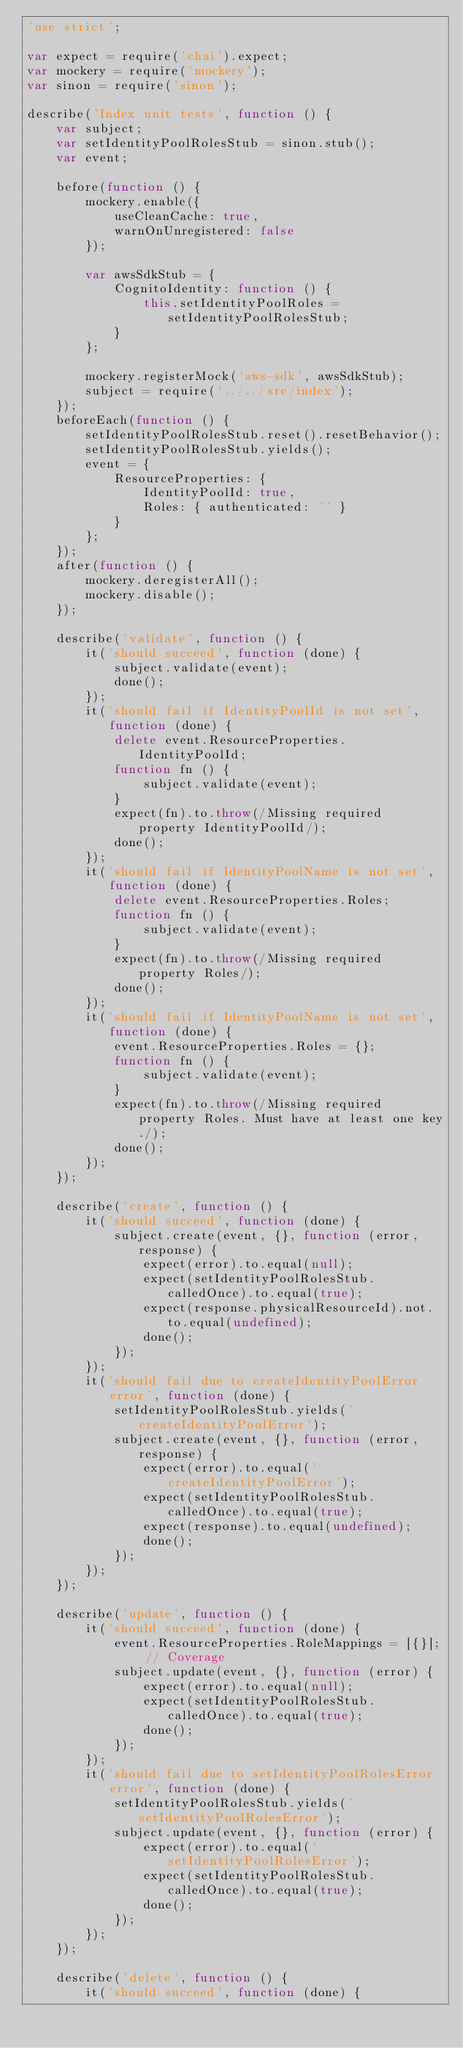<code> <loc_0><loc_0><loc_500><loc_500><_JavaScript_>'use strict';

var expect = require('chai').expect;
var mockery = require('mockery');
var sinon = require('sinon');

describe('Index unit tests', function () {
    var subject;
    var setIdentityPoolRolesStub = sinon.stub();
    var event;

    before(function () {
        mockery.enable({
            useCleanCache: true,
            warnOnUnregistered: false
        });

        var awsSdkStub = {
            CognitoIdentity: function () {
                this.setIdentityPoolRoles = setIdentityPoolRolesStub;
            }
        };

        mockery.registerMock('aws-sdk', awsSdkStub);
        subject = require('../../src/index');
    });
    beforeEach(function () {
        setIdentityPoolRolesStub.reset().resetBehavior();
        setIdentityPoolRolesStub.yields();
        event = {
            ResourceProperties: {
                IdentityPoolId: true,
                Roles: { authenticated: '' }
            }
        };
    });
    after(function () {
        mockery.deregisterAll();
        mockery.disable();
    });

    describe('validate', function () {
        it('should succeed', function (done) {
            subject.validate(event);
            done();
        });
        it('should fail if IdentityPoolId is not set', function (done) {
            delete event.ResourceProperties.IdentityPoolId;
            function fn () {
                subject.validate(event);
            }
            expect(fn).to.throw(/Missing required property IdentityPoolId/);
            done();
        });
        it('should fail if IdentityPoolName is not set', function (done) {
            delete event.ResourceProperties.Roles;
            function fn () {
                subject.validate(event);
            }
            expect(fn).to.throw(/Missing required property Roles/);
            done();
        });
        it('should fail if IdentityPoolName is not set', function (done) {
            event.ResourceProperties.Roles = {};
            function fn () {
                subject.validate(event);
            }
            expect(fn).to.throw(/Missing required property Roles. Must have at least one key./);
            done();
        });
    });

    describe('create', function () {
        it('should succeed', function (done) {
            subject.create(event, {}, function (error, response) {
                expect(error).to.equal(null);
                expect(setIdentityPoolRolesStub.calledOnce).to.equal(true);
                expect(response.physicalResourceId).not.to.equal(undefined);
                done();
            });
        });
        it('should fail due to createIdentityPoolError error', function (done) {
            setIdentityPoolRolesStub.yields('createIdentityPoolError');
            subject.create(event, {}, function (error, response) {
                expect(error).to.equal('createIdentityPoolError');
                expect(setIdentityPoolRolesStub.calledOnce).to.equal(true);
                expect(response).to.equal(undefined);
                done();
            });
        });
    });

    describe('update', function () {
        it('should succeed', function (done) {
            event.ResourceProperties.RoleMappings = [{}]; // Coverage
            subject.update(event, {}, function (error) {
                expect(error).to.equal(null);
                expect(setIdentityPoolRolesStub.calledOnce).to.equal(true);
                done();
            });
        });
        it('should fail due to setIdentityPoolRolesError error', function (done) {
            setIdentityPoolRolesStub.yields('setIdentityPoolRolesError');
            subject.update(event, {}, function (error) {
                expect(error).to.equal('setIdentityPoolRolesError');
                expect(setIdentityPoolRolesStub.calledOnce).to.equal(true);
                done();
            });
        });
    });

    describe('delete', function () {
        it('should succeed', function (done) {</code> 